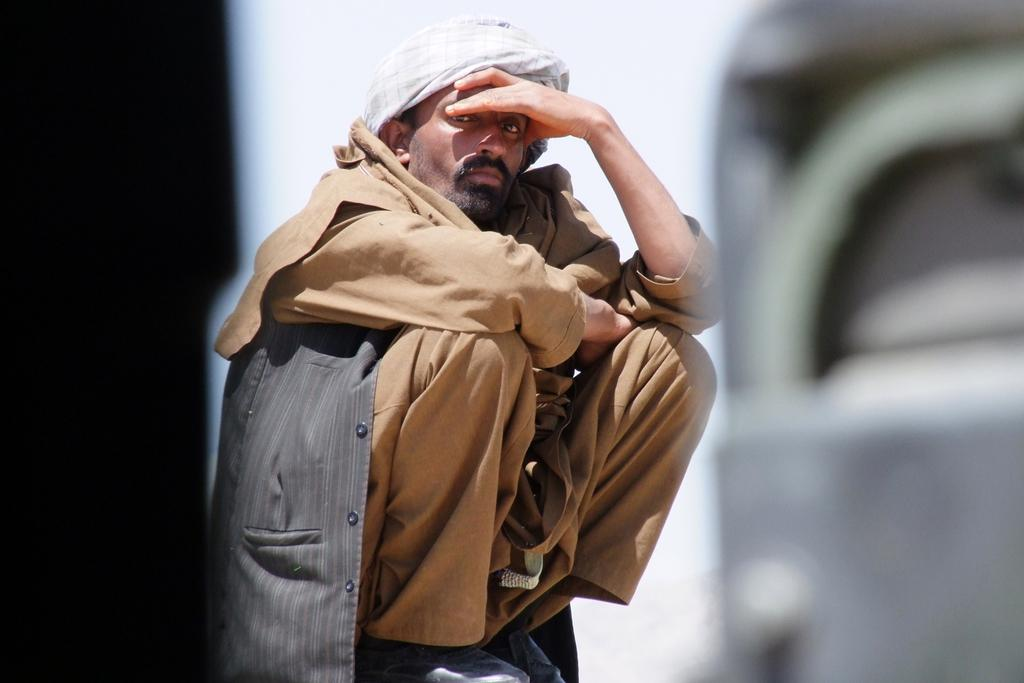Who is the main subject in the image? There is a person in the center of the image. What is the person doing in the image? The person is in a squat position. What is the person wearing in the image? The person is wearing a different costume. Can you describe the background of the image? The background of the image is blurred. What type of noise can be heard coming from the garden in the image? There is no garden or noise present in the image; it features a person in a squat position wearing a different costume with a blurred background. 